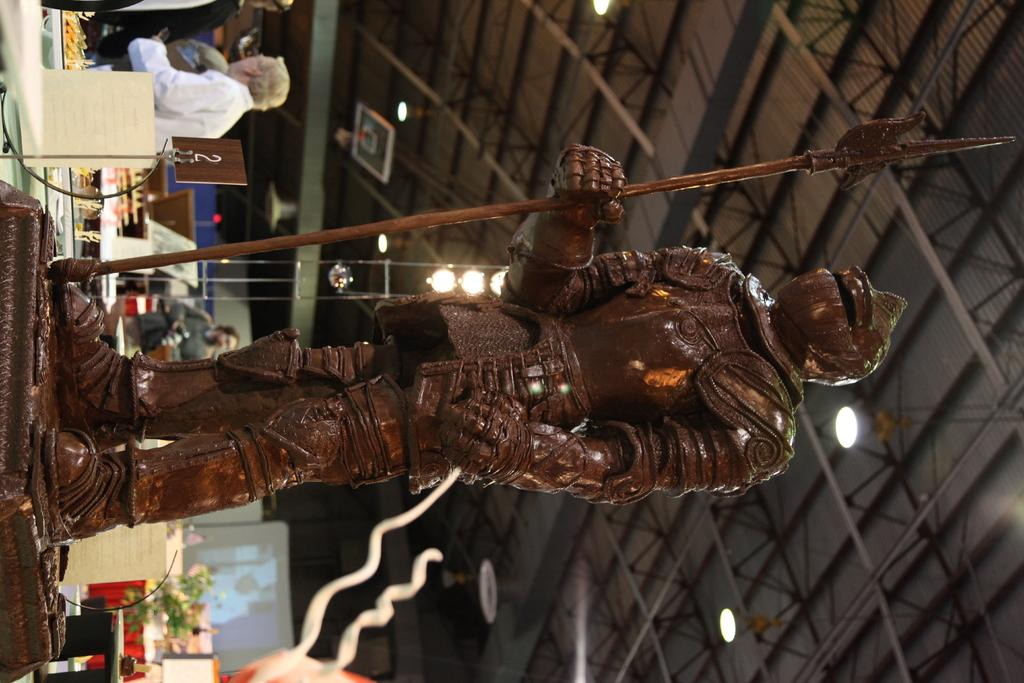How is the image oriented? The image is tilted. What type of structure can be seen in the image? There is a roof visible in the image. What can be used for illumination in the image? There are lights in the image. What type of artwork or sculpture is present in the image? There is a statue in the image. Who or what is present in the image? There are people in the image. What is used for displaying visual content in the image? There is a projector screen in the image. What other objects can be seen in the image besides those mentioned? There are other objects present in the image. How many pizzas are being served on the projector screen in the image? There are no pizzas present in the image, and the projector screen is not serving food. What type of pie is being eaten by the statue in the image? There is no pie present in the image, and the statue is not depicted as eating anything. 